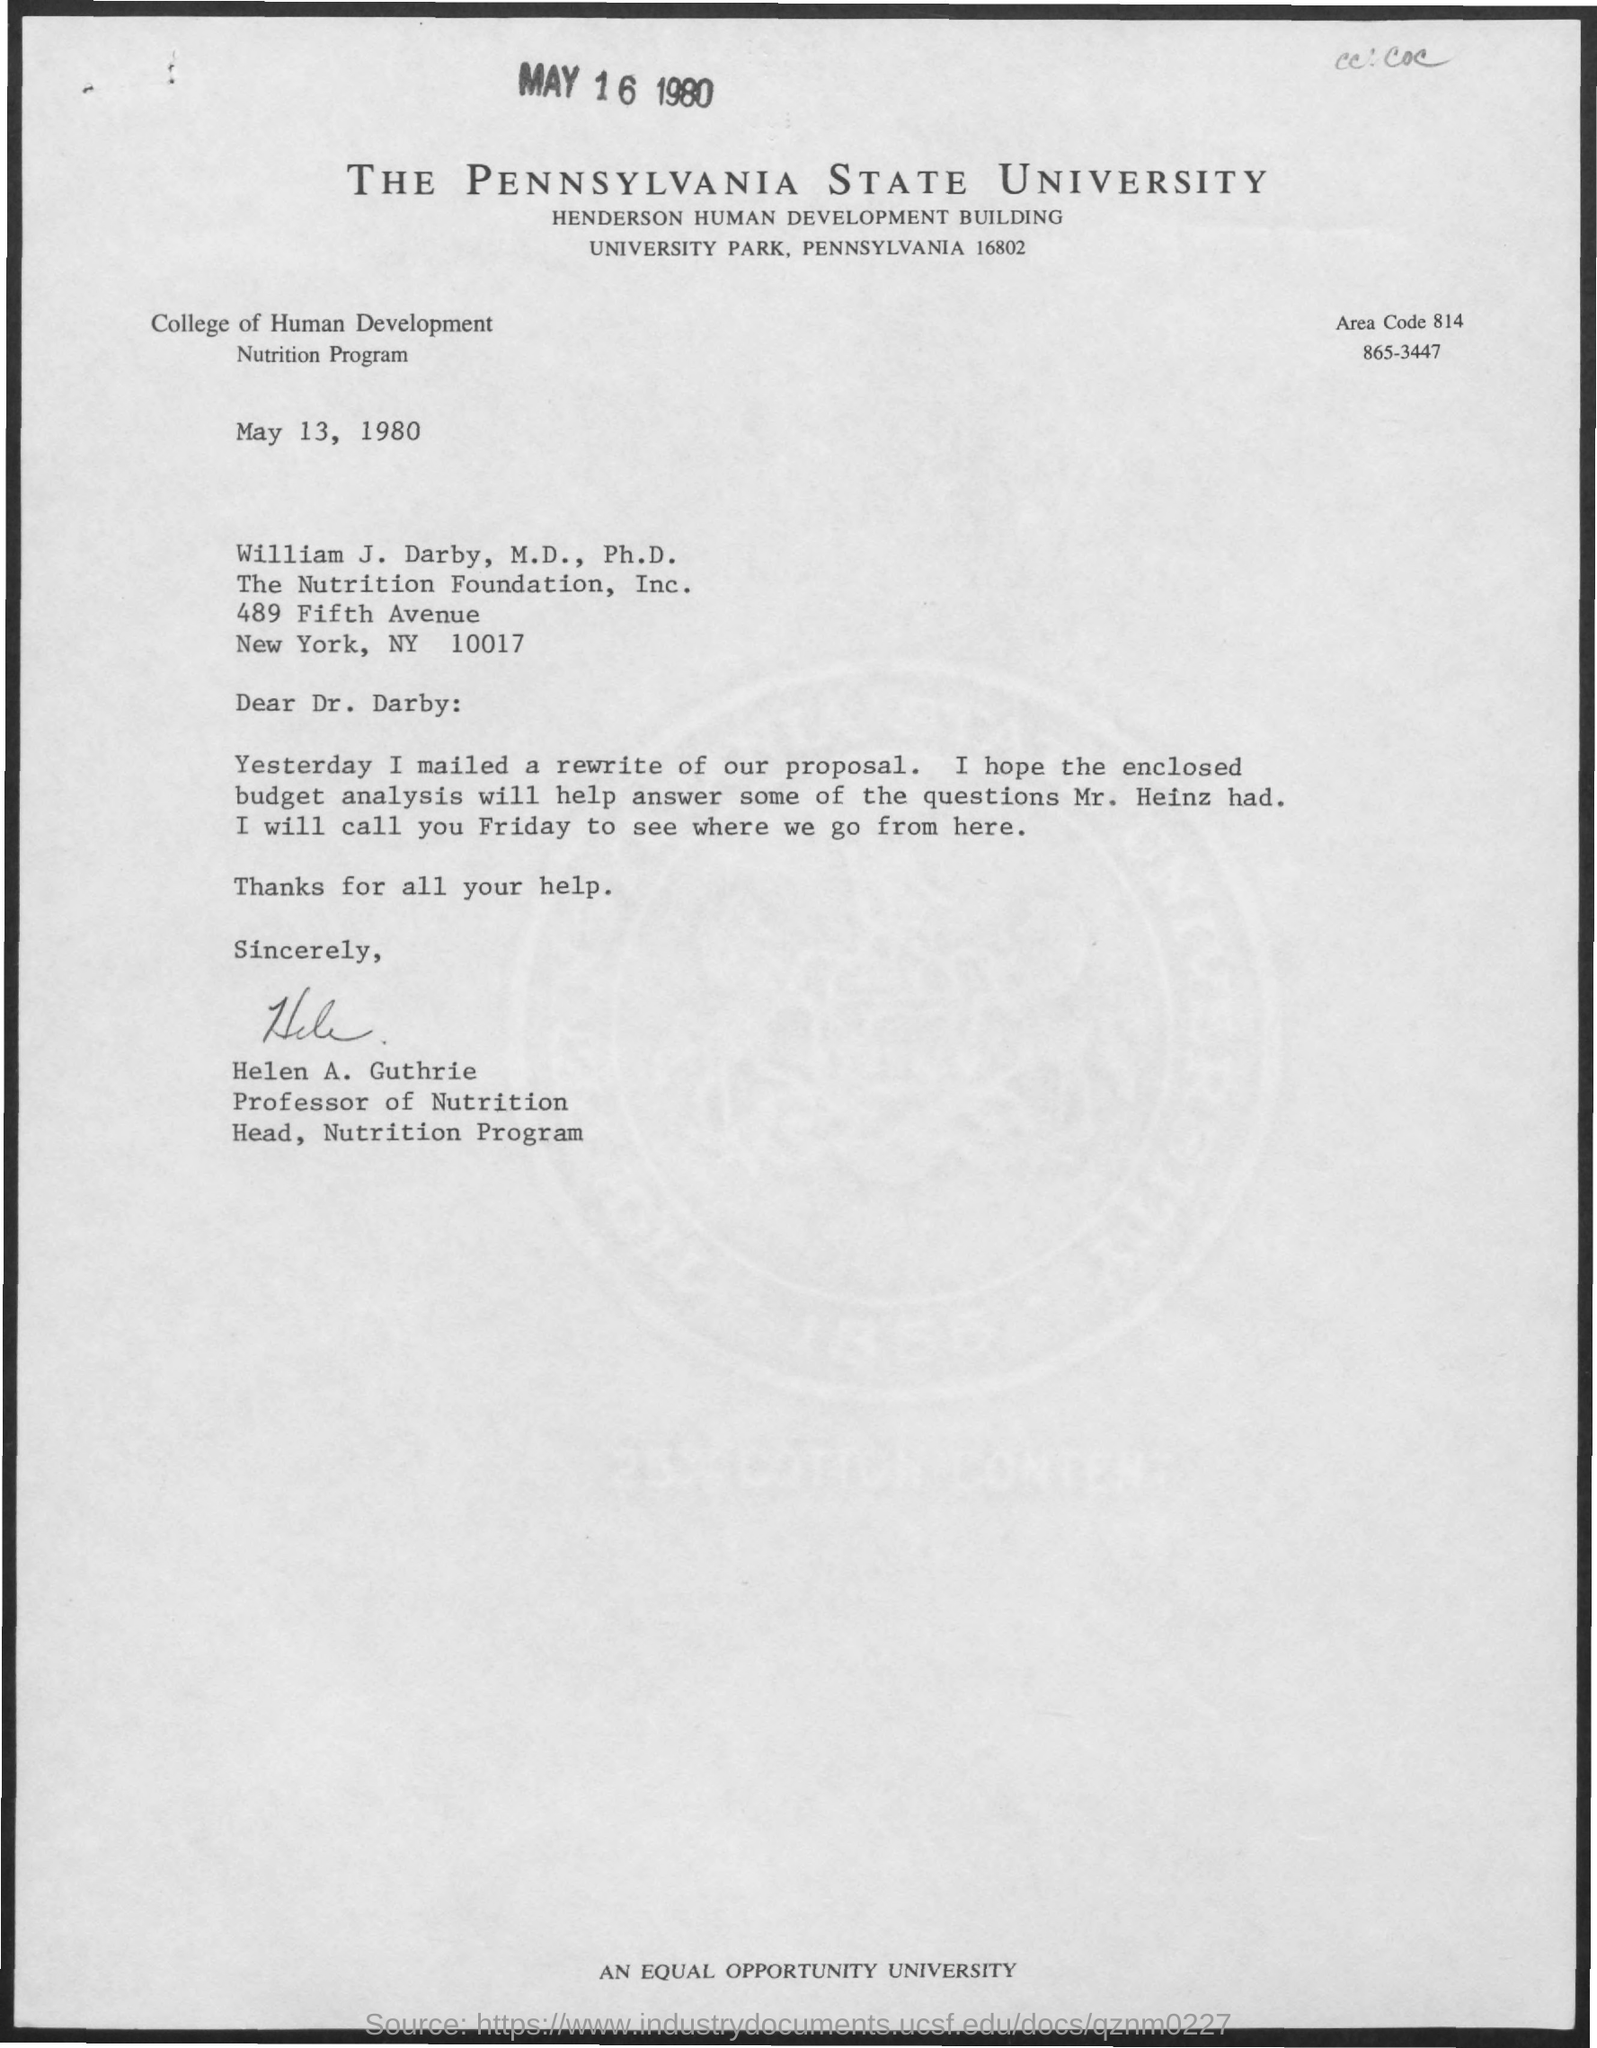What is the name of the university mentioned in the given form ?
Offer a terse response. THE PENNSYLVANIA STATE UNIVERSITY. What is the name of the college mentioned ?
Give a very brief answer. College of Human Development. What is the area code mentioned in the given form ?
Offer a terse response. 814. What is the name of the building mentioned ?
Make the answer very short. HENDERSON HUMAN DEVELOPMENT BUILDING. What is the date mentioned at the top of the page ?
Provide a succinct answer. MAY 16 1980. Who's sign was there at the bottom of the letter ?
Your answer should be compact. Helen A. Guthrie. 